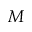<formula> <loc_0><loc_0><loc_500><loc_500>M</formula> 